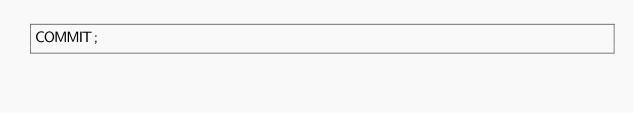Convert code to text. <code><loc_0><loc_0><loc_500><loc_500><_SQL_>COMMIT;

</code> 